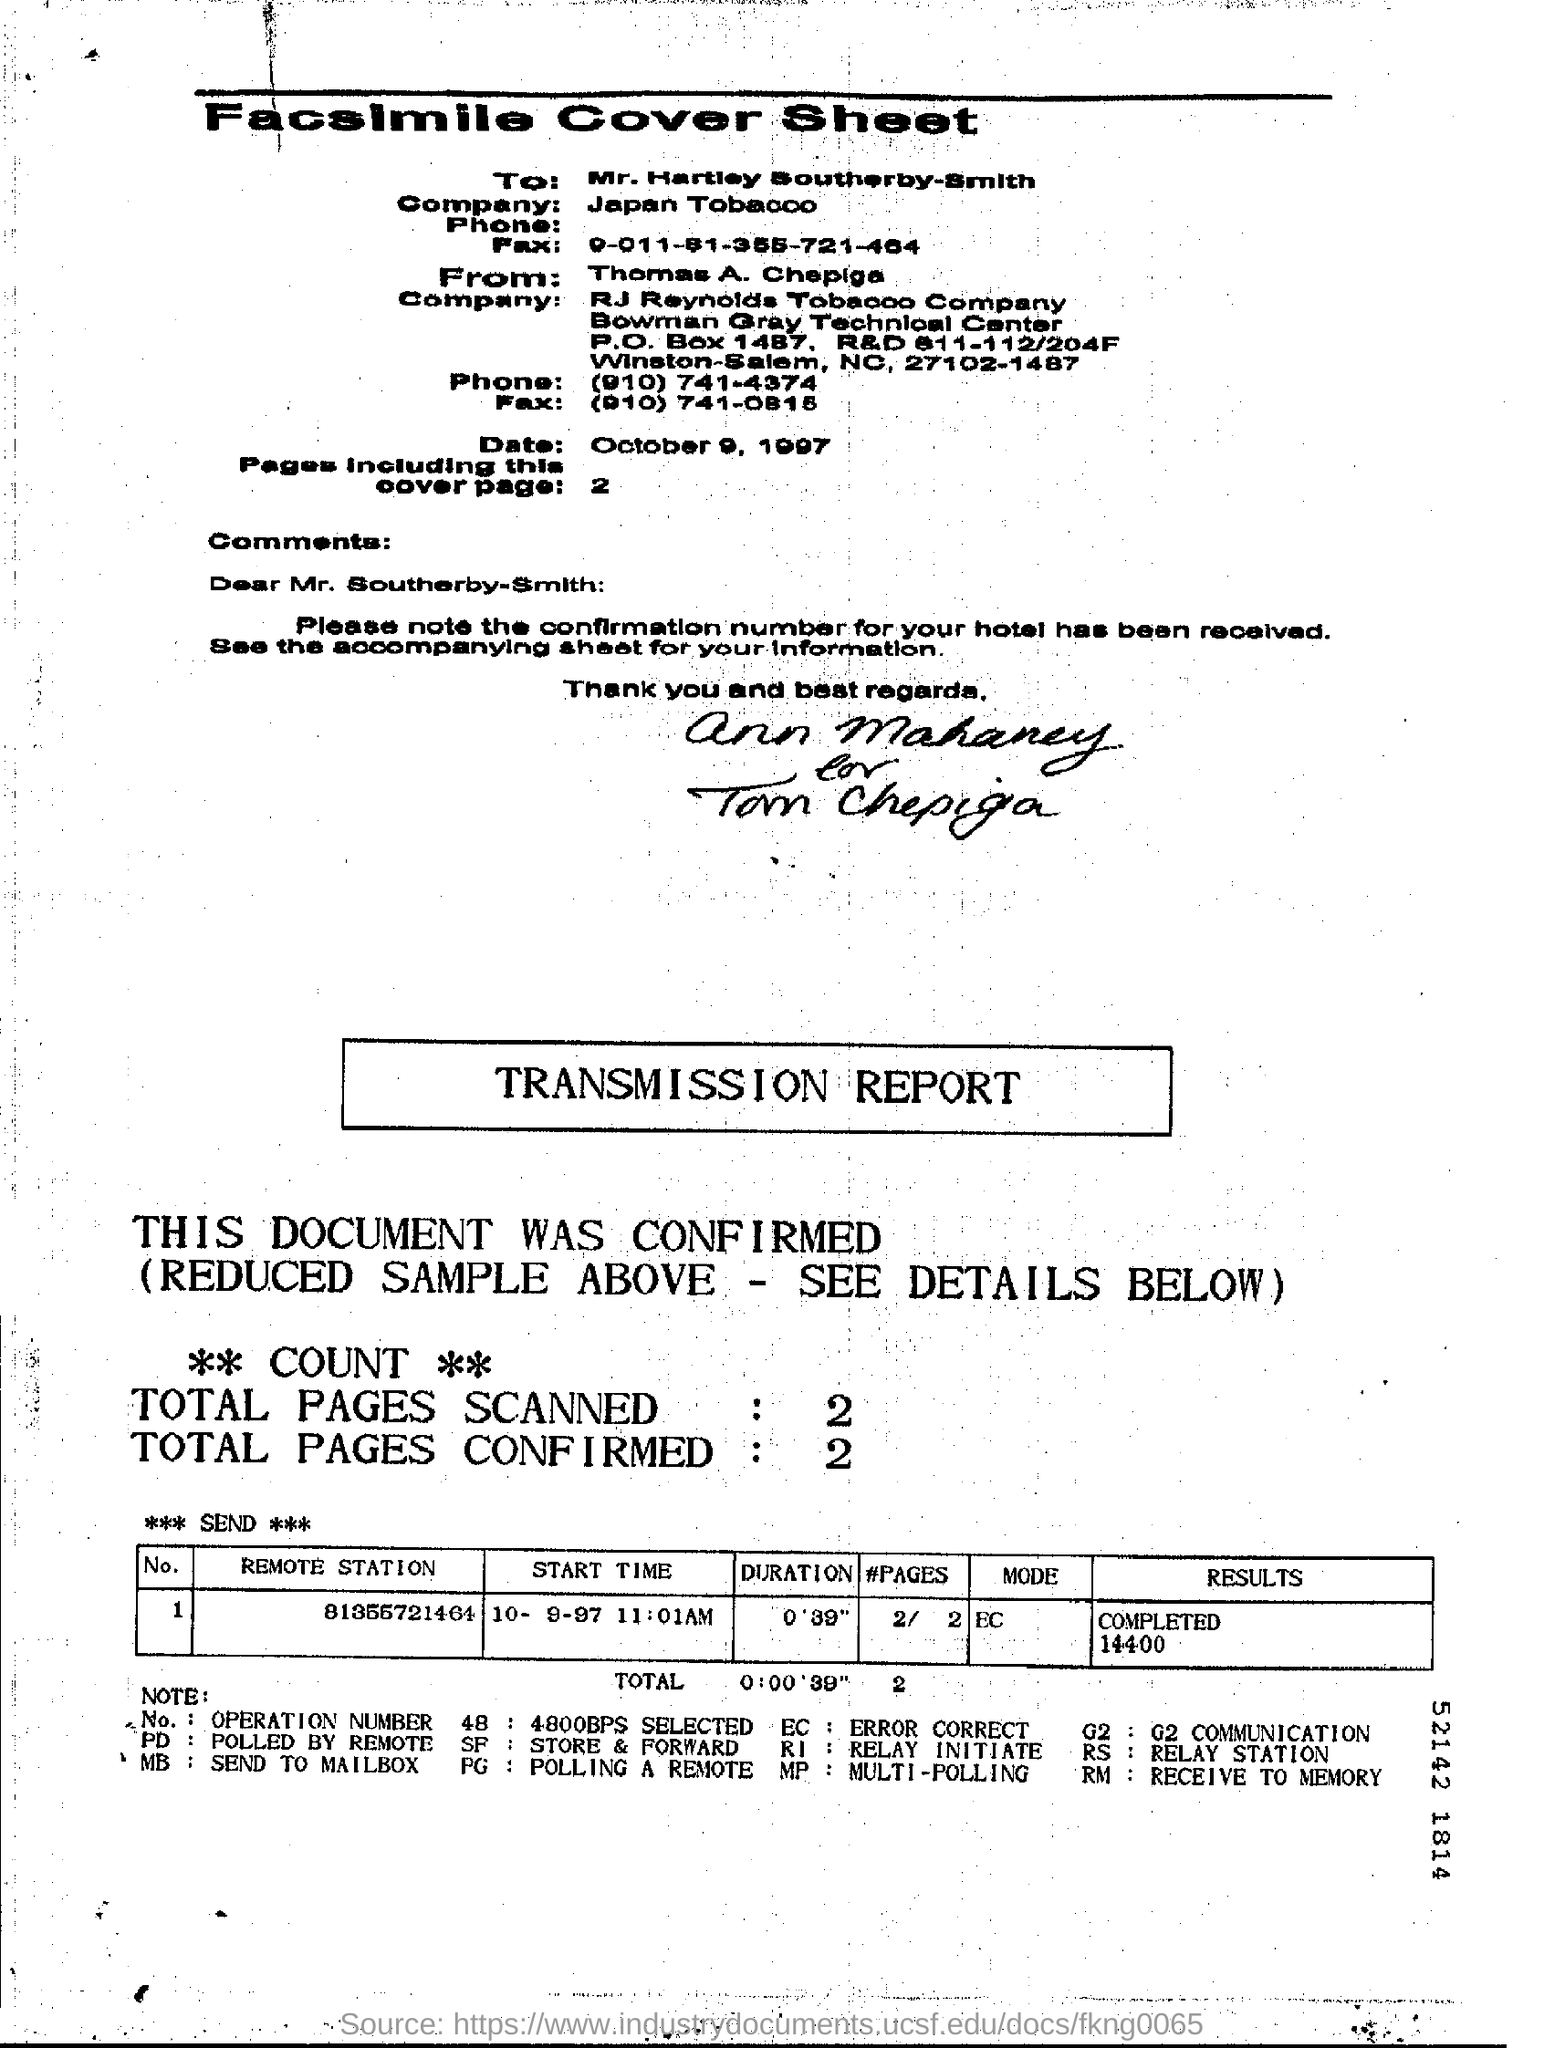Identify some key points in this picture. Which remote station is assigned to Operation Number 1? The Start time mentioned in the transmission report is 10-9-97 11:01 AM. There are two pages in the fax, including the cover page, according to the information provided. 